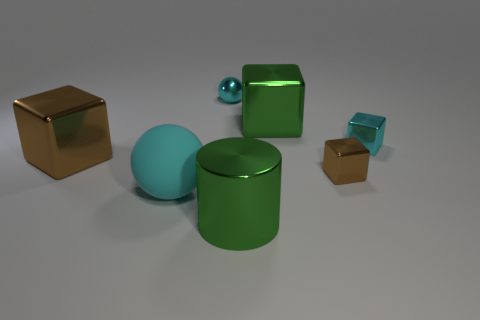Subtract all cyan balls. How many were subtracted if there are1cyan balls left? 1 Subtract all small cyan cubes. How many cubes are left? 3 Add 1 brown objects. How many objects exist? 8 Subtract all gray balls. How many brown blocks are left? 2 Subtract all green blocks. How many blocks are left? 3 Subtract all balls. How many objects are left? 5 Subtract all yellow spheres. Subtract all yellow cylinders. How many spheres are left? 2 Subtract all cyan objects. Subtract all brown cubes. How many objects are left? 2 Add 3 large brown blocks. How many large brown blocks are left? 4 Add 4 cyan cubes. How many cyan cubes exist? 5 